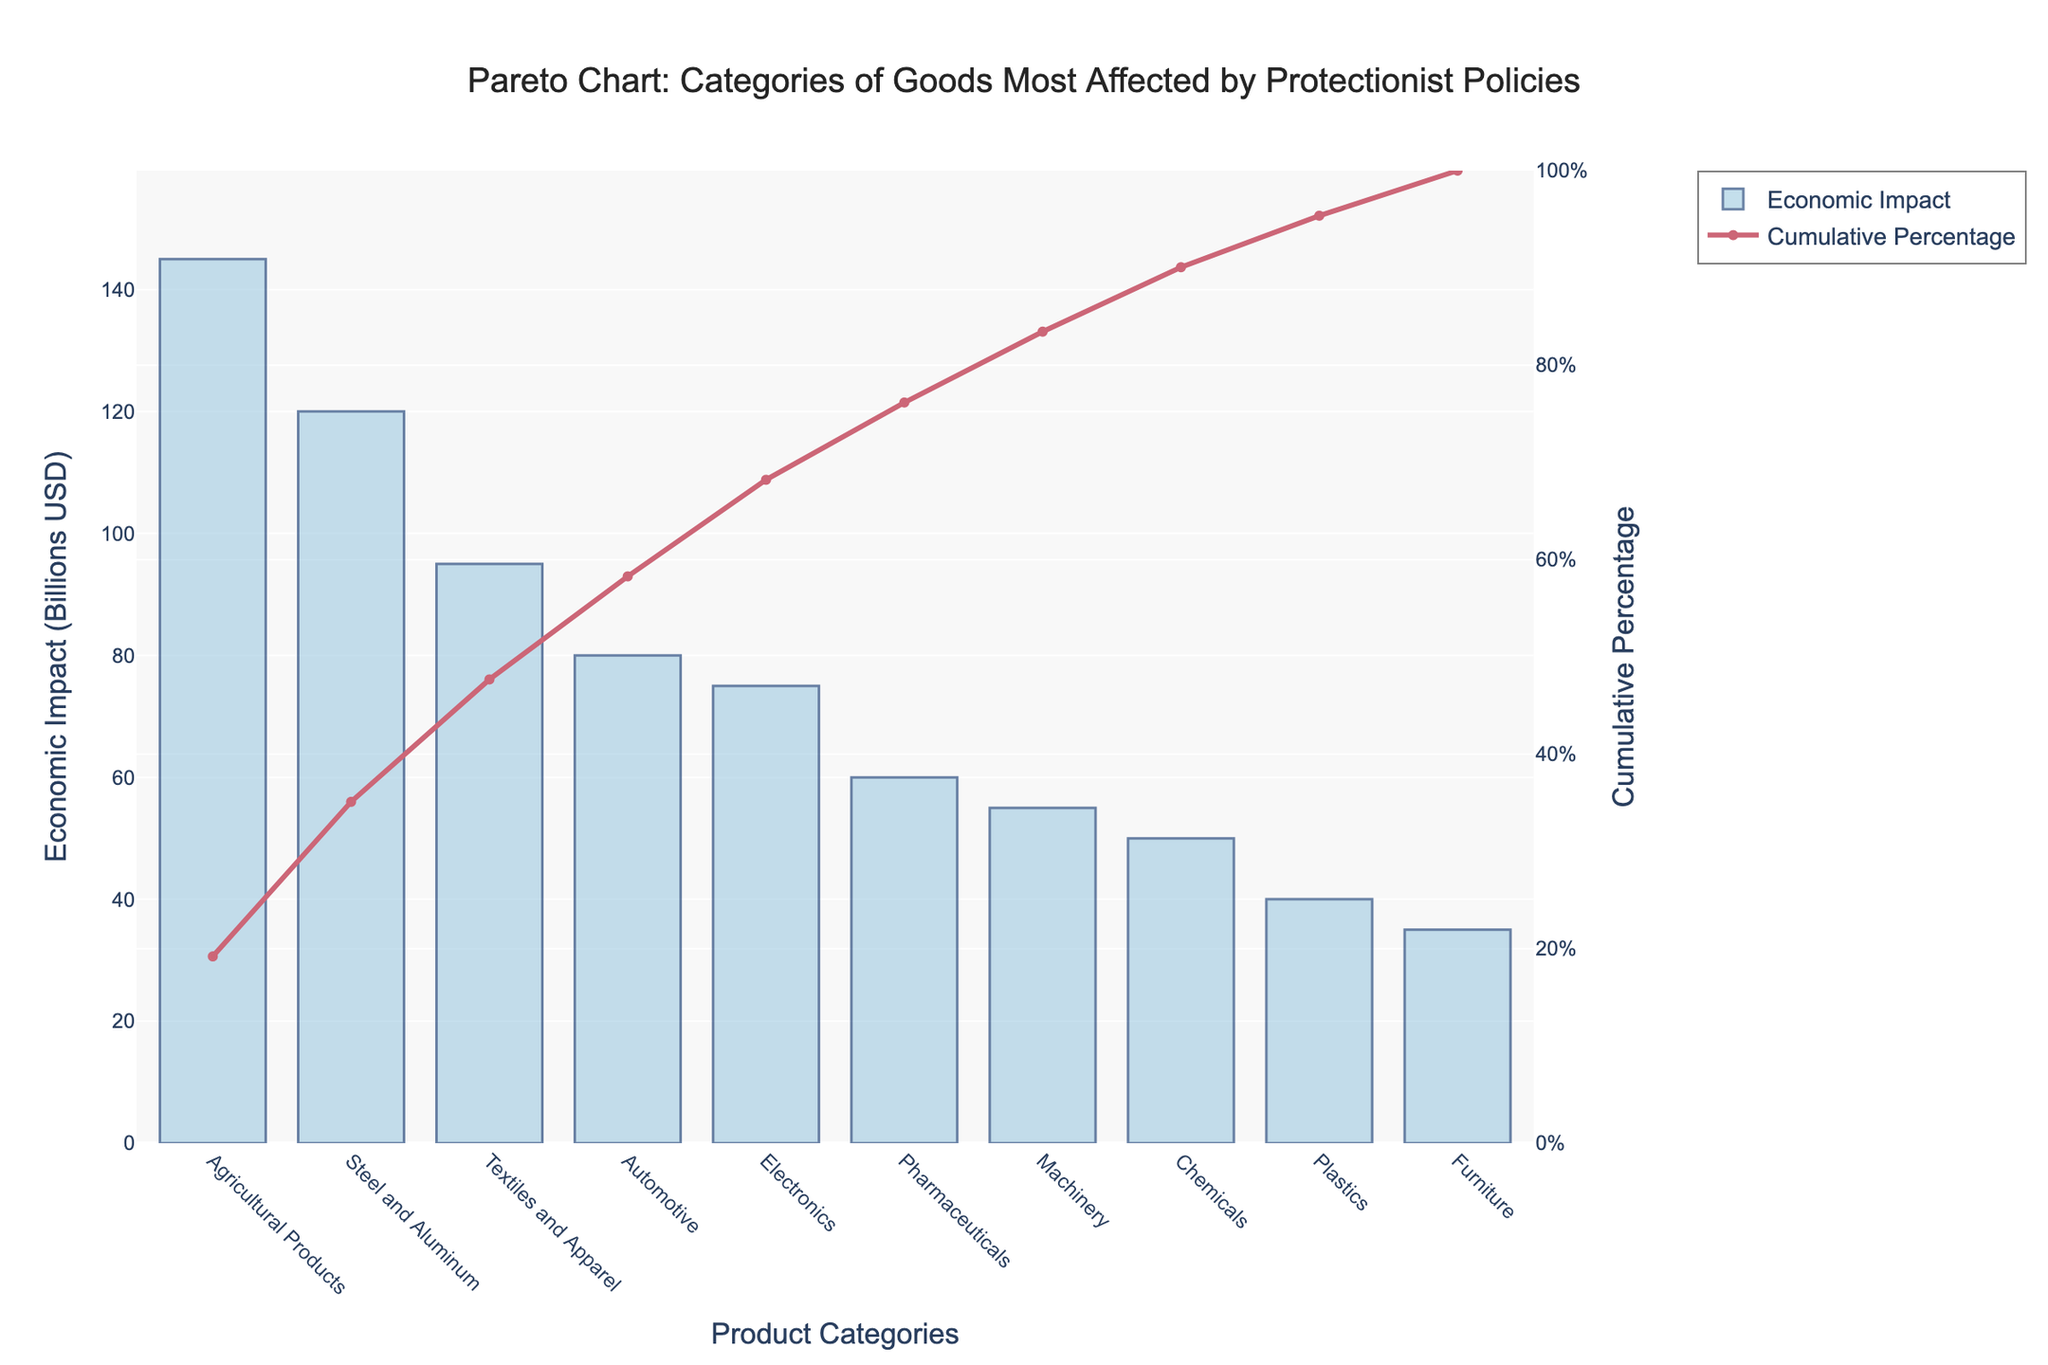What is the category with the highest economic impact? Looking at the chart, the category with the tallest bar represents the goods with the highest economic impact.
Answer: Agricultural Products What is the cumulative percentage after adding the impact of Steel and Aluminum? The cumulative percentage line at the top of the bar for Steel and Aluminum shows the percentage after adding its impact.
Answer: 35.4% Which categories have a cumulative percentage below 50%? We identify categories from the chart's left side until the cumulative percentage line crosses 50%.
Answer: Agricultural Products, Steel and Aluminum, and Textiles and Apparel How much more economic impact do Agricultural Products have compared to Electronics? Subtract the economic impact of Electronics from Agricultural Products.
Answer: 70 billion USD Which category ranks third in terms of economic impact? The third tallest bar in the chart represents the third most impacted category.
Answer: Textiles and Apparel What is the economic impact of the Machinery category? The height of the bar labeled "Machinery" indicates its economic impact.
Answer: 55 billion USD Nearly what percentage of the total economic impact is covered by Automotive, Electronics, Pharmaceuticals, and Machinery together? Add the economic impacts of Automotive, Electronics, Pharmaceuticals, and Machinery, then divide by the total and convert to a percentage.
Answer: 48.6% How do the impacts of Chemicals and Plastics compare? Compare the heights of the bars labeled Chemicals and Plastics.
Answer: Chemicals have a higher economic impact than Plastics What percentage of the total economic impact is constituted by the top three categories combined? Sum the economic impacts of the top three categories and divide by the total, then convert to a percentage.
Answer: 74% What is the cumulative percentage of the bottom four categories together? Sum the cumulative percentages at the end of each added category starting from the fourth-lowest bar to the lowest.
Answer: 88.9% 